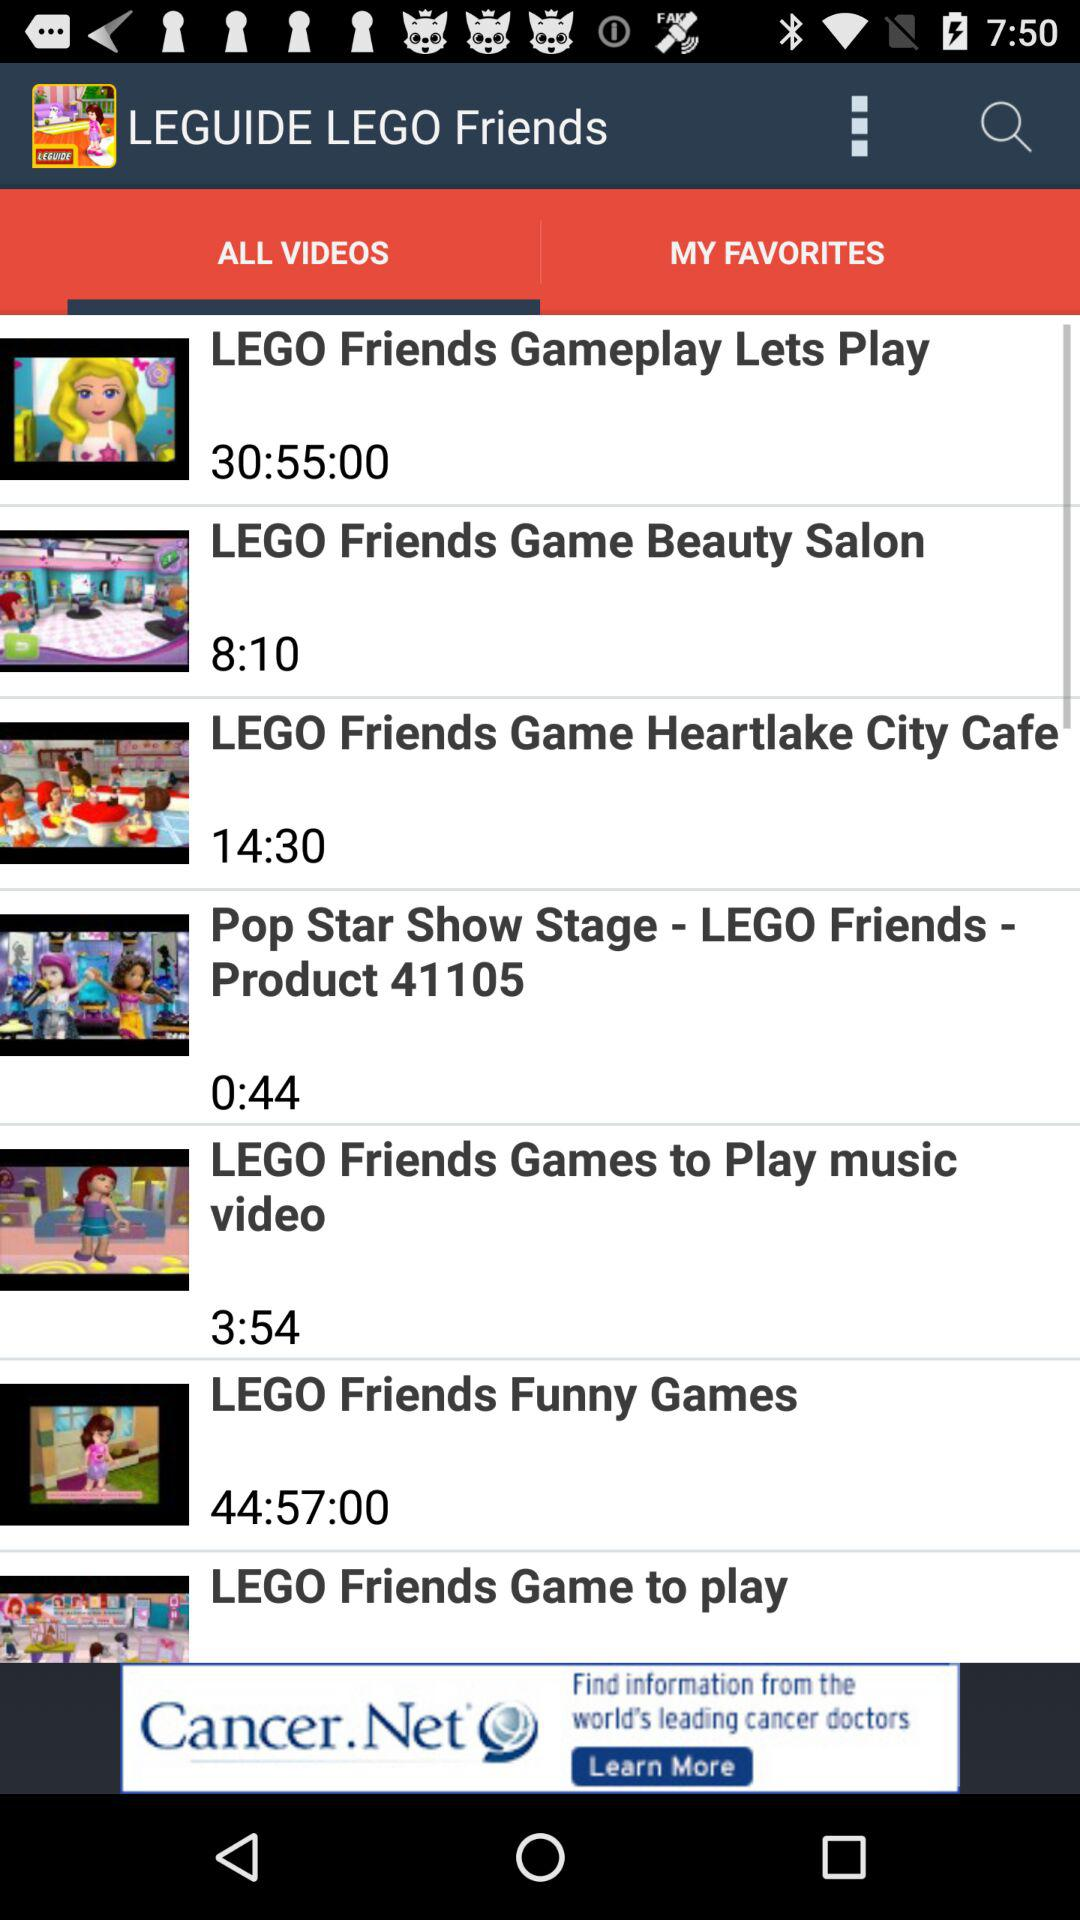What is the name of the application? The name of the application is "LEGUIDE LEGO Friends". 